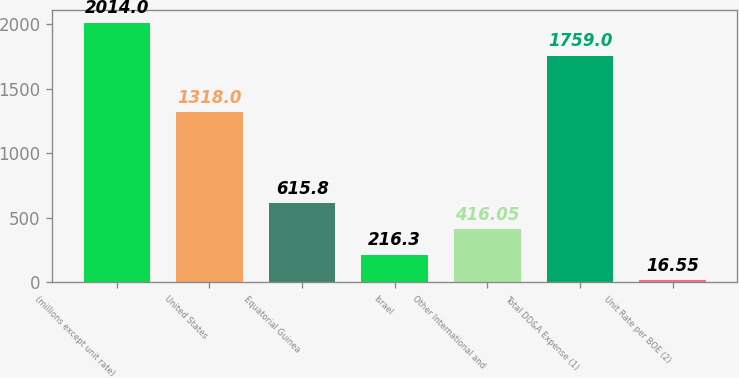<chart> <loc_0><loc_0><loc_500><loc_500><bar_chart><fcel>(millions except unit rate)<fcel>United States<fcel>Equatorial Guinea<fcel>Israel<fcel>Other International and<fcel>Total DD&A Expense (1)<fcel>Unit Rate per BOE (2)<nl><fcel>2014<fcel>1318<fcel>615.8<fcel>216.3<fcel>416.05<fcel>1759<fcel>16.55<nl></chart> 